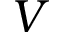<formula> <loc_0><loc_0><loc_500><loc_500>V</formula> 